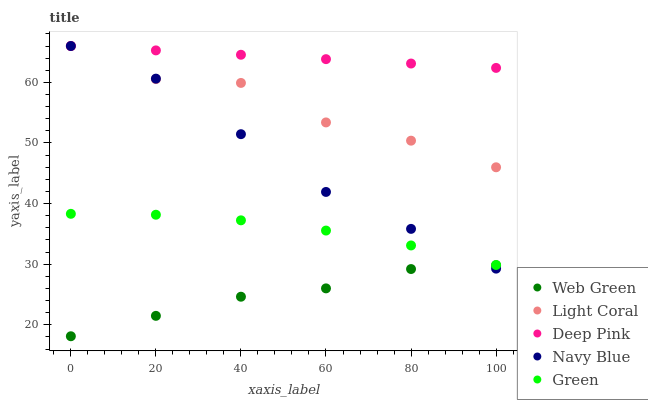Does Web Green have the minimum area under the curve?
Answer yes or no. Yes. Does Deep Pink have the maximum area under the curve?
Answer yes or no. Yes. Does Navy Blue have the minimum area under the curve?
Answer yes or no. No. Does Navy Blue have the maximum area under the curve?
Answer yes or no. No. Is Deep Pink the smoothest?
Answer yes or no. Yes. Is Light Coral the roughest?
Answer yes or no. Yes. Is Navy Blue the smoothest?
Answer yes or no. No. Is Navy Blue the roughest?
Answer yes or no. No. Does Web Green have the lowest value?
Answer yes or no. Yes. Does Navy Blue have the lowest value?
Answer yes or no. No. Does Deep Pink have the highest value?
Answer yes or no. Yes. Does Green have the highest value?
Answer yes or no. No. Is Green less than Deep Pink?
Answer yes or no. Yes. Is Deep Pink greater than Green?
Answer yes or no. Yes. Does Light Coral intersect Navy Blue?
Answer yes or no. Yes. Is Light Coral less than Navy Blue?
Answer yes or no. No. Is Light Coral greater than Navy Blue?
Answer yes or no. No. Does Green intersect Deep Pink?
Answer yes or no. No. 